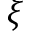Convert formula to latex. <formula><loc_0><loc_0><loc_500><loc_500>\xi</formula> 